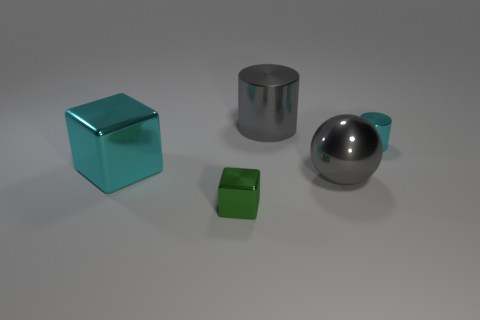Are there any big metal spheres behind the gray cylinder?
Your response must be concise. No. There is a sphere that is the same size as the cyan block; what is its color?
Give a very brief answer. Gray. How many things are objects that are to the right of the large metal sphere or large cyan metal things?
Give a very brief answer. 2. There is a thing that is on the left side of the big cylinder and on the right side of the cyan metallic block; how big is it?
Keep it short and to the point. Small. The object that is the same color as the big metal block is what size?
Ensure brevity in your answer.  Small. What number of other objects are the same size as the cyan cylinder?
Offer a very short reply. 1. There is a metal cylinder that is left of the cyan shiny thing that is to the right of the gray thing to the right of the large gray cylinder; what is its color?
Provide a short and direct response. Gray. There is a object that is both to the left of the large gray metallic sphere and in front of the cyan cube; what shape is it?
Ensure brevity in your answer.  Cube. What number of other objects are the same shape as the big cyan object?
Provide a short and direct response. 1. There is a small metal object on the left side of the cylinder that is on the right side of the big gray metallic object behind the large cyan metallic thing; what shape is it?
Provide a succinct answer. Cube. 